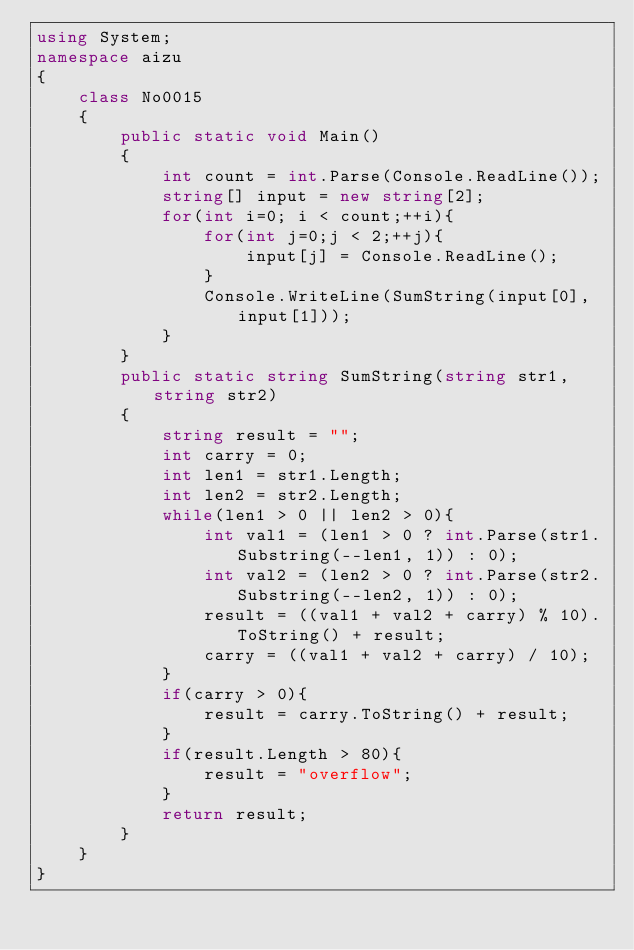Convert code to text. <code><loc_0><loc_0><loc_500><loc_500><_C#_>using System;
namespace aizu
{
    class No0015
    {
        public static void Main()
        {
            int count = int.Parse(Console.ReadLine());
            string[] input = new string[2];
            for(int i=0; i < count;++i){
                for(int j=0;j < 2;++j){
                    input[j] = Console.ReadLine();
                }
                Console.WriteLine(SumString(input[0], input[1]));
            }
        }
        public static string SumString(string str1, string str2)
        {
            string result = "";
            int carry = 0;
            int len1 = str1.Length;
            int len2 = str2.Length;
            while(len1 > 0 || len2 > 0){
                int val1 = (len1 > 0 ? int.Parse(str1.Substring(--len1, 1)) : 0);
                int val2 = (len2 > 0 ? int.Parse(str2.Substring(--len2, 1)) : 0);
                result = ((val1 + val2 + carry) % 10).ToString() + result;
                carry = ((val1 + val2 + carry) / 10);
            }
            if(carry > 0){
                result = carry.ToString() + result;
            }
            if(result.Length > 80){
                result = "overflow";
            }
            return result;
        }
    }
}</code> 